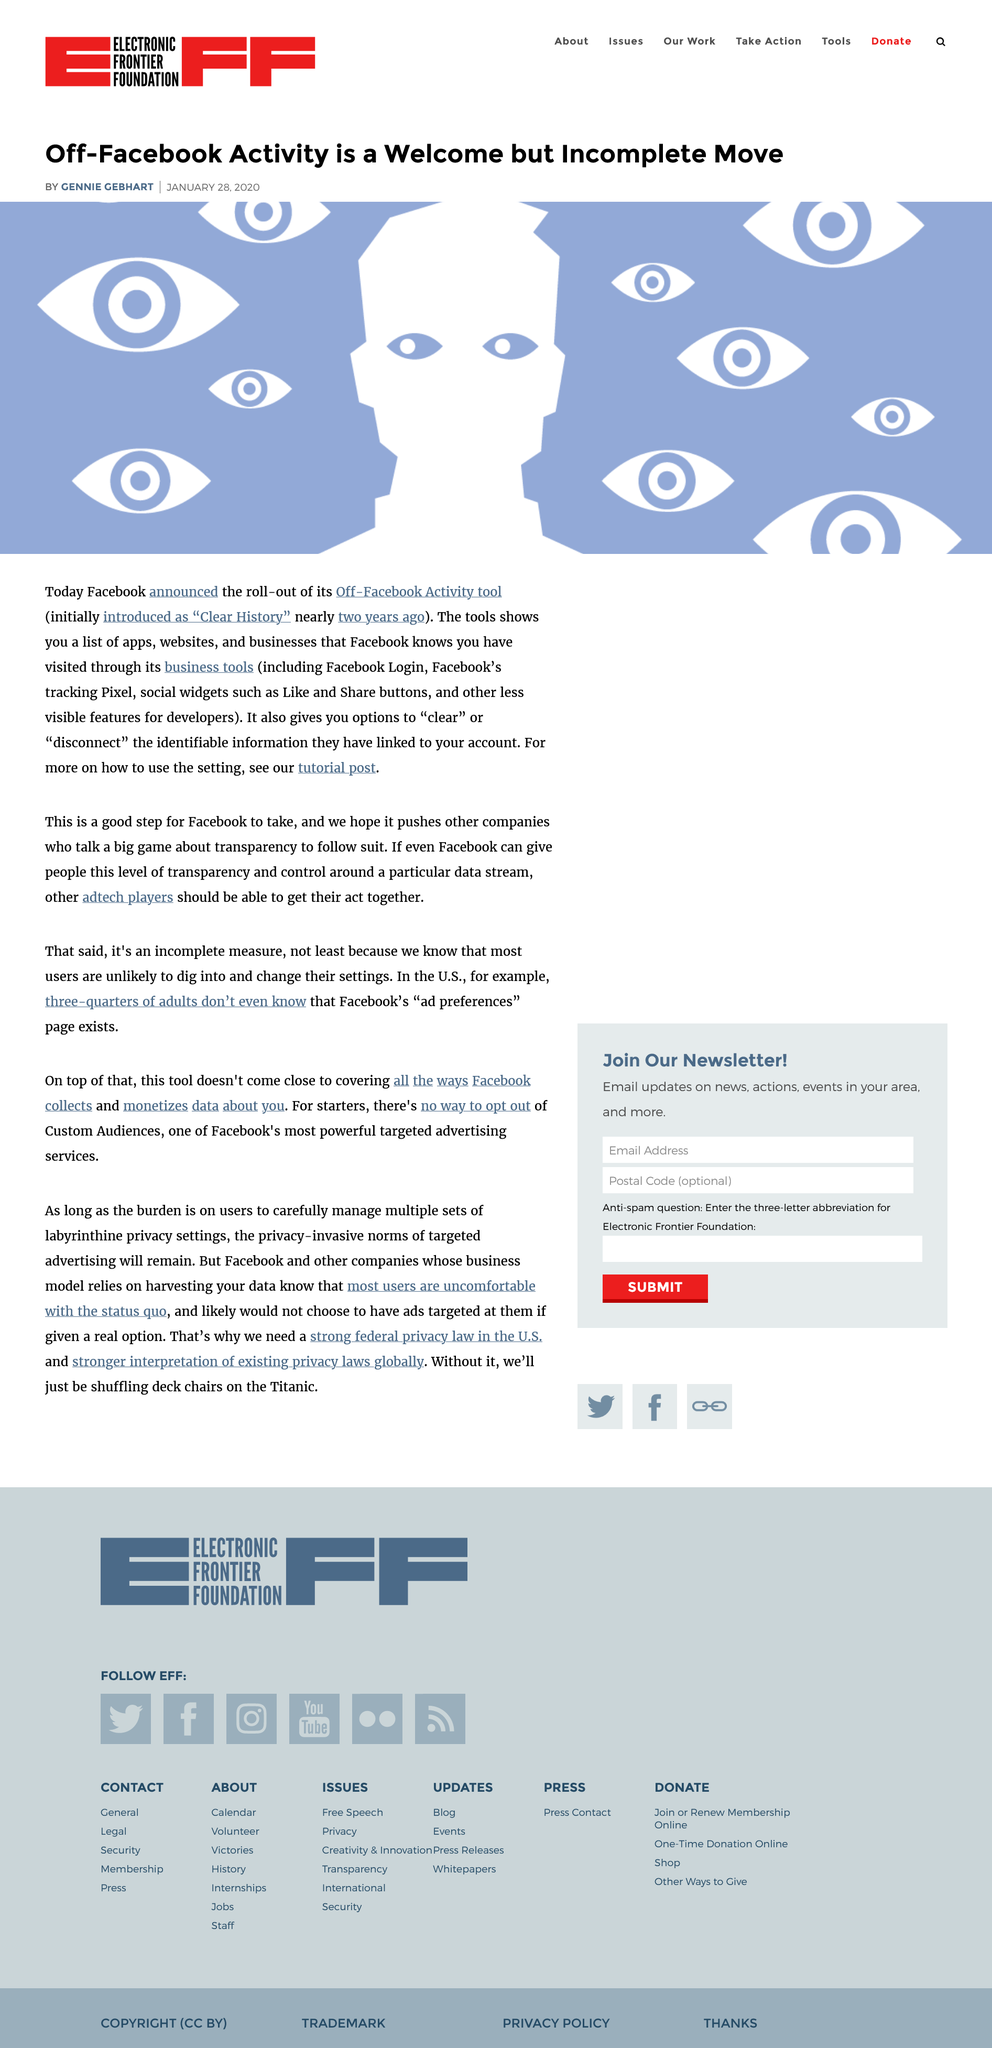List a handful of essential elements in this visual. The article was published on January 28th, 2020. The article is focused on Facebook. 